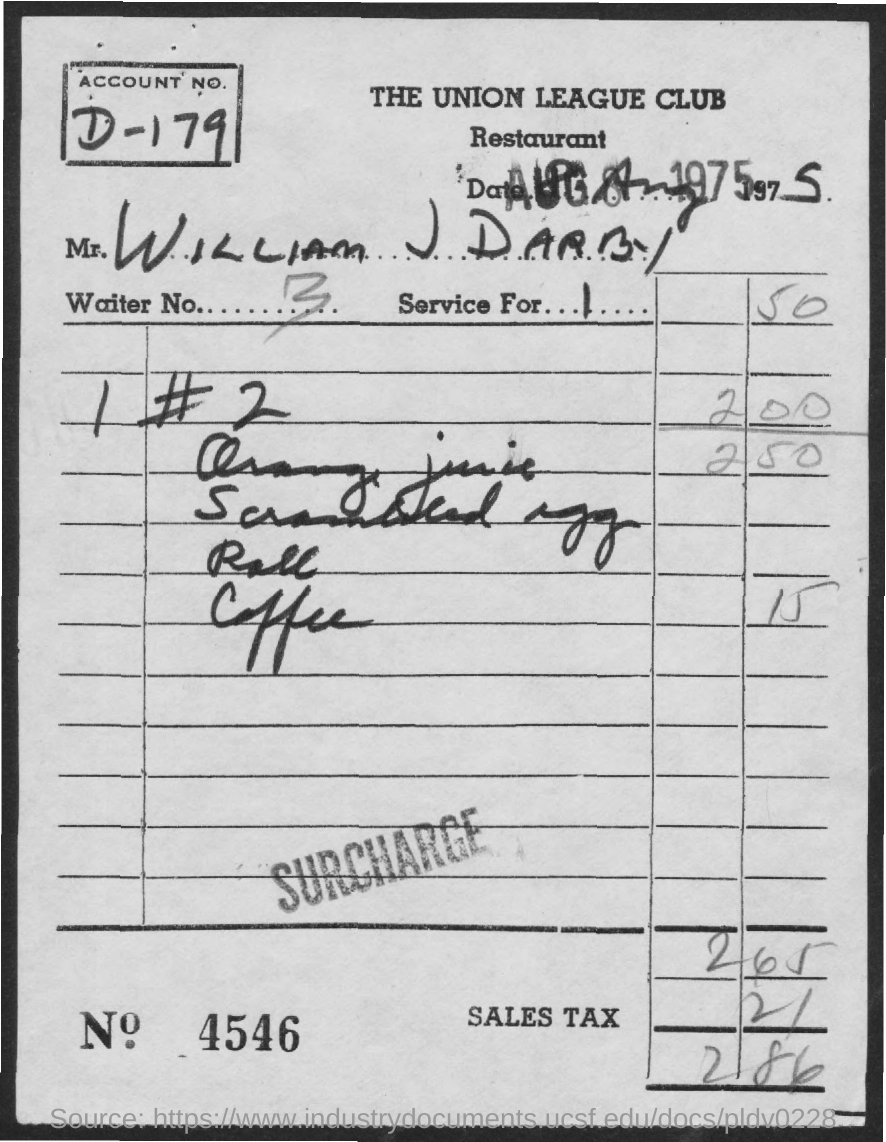Draw attention to some important aspects in this diagram. To what extent is the service for? The Waiter number is 3. What is the bill number? 4546... The name of the restaurant is The Union League Club. The total amount is 2.86. 